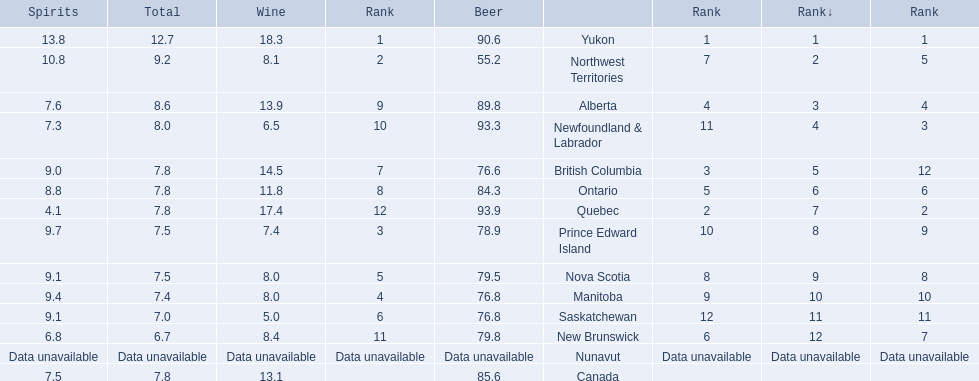Which country ranks #1 in alcoholic beverage consumption? Yukon. Of that country, how many total liters of spirits do they consume? 12.7. 